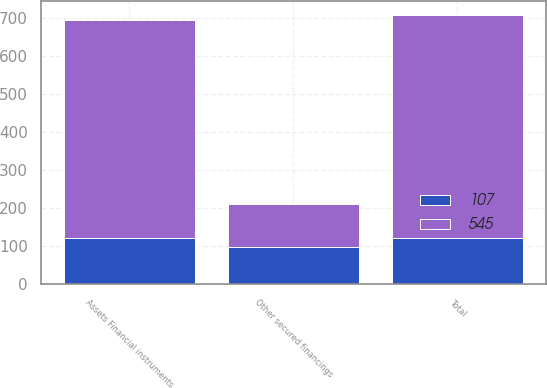Convert chart. <chart><loc_0><loc_0><loc_500><loc_500><stacked_bar_chart><ecel><fcel>Assets Financial instruments<fcel>Total<fcel>Other secured financings<nl><fcel>545<fcel>572<fcel>587<fcel>113<nl><fcel>107<fcel>121<fcel>121<fcel>99<nl></chart> 